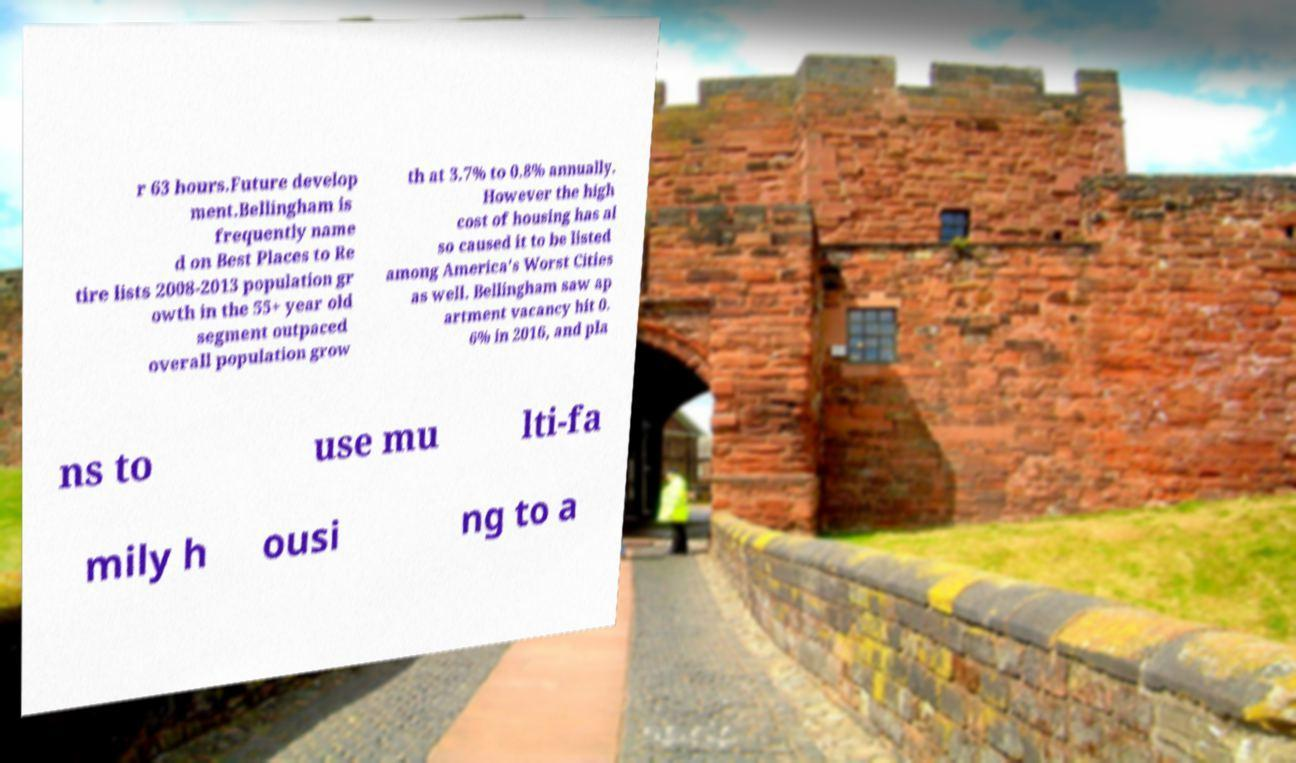What messages or text are displayed in this image? I need them in a readable, typed format. r 63 hours.Future develop ment.Bellingham is frequently name d on Best Places to Re tire lists 2008-2013 population gr owth in the 55+ year old segment outpaced overall population grow th at 3.7% to 0.8% annually. However the high cost of housing has al so caused it to be listed among America's Worst Cities as well. Bellingham saw ap artment vacancy hit 0. 6% in 2016, and pla ns to use mu lti-fa mily h ousi ng to a 